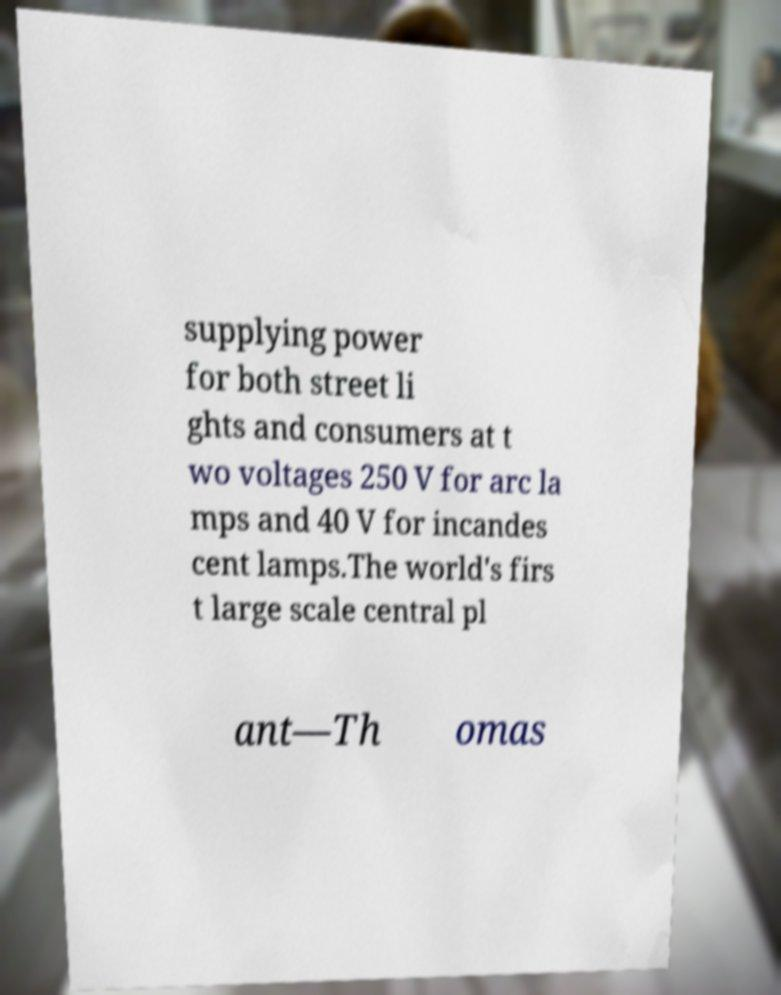Can you accurately transcribe the text from the provided image for me? supplying power for both street li ghts and consumers at t wo voltages 250 V for arc la mps and 40 V for incandes cent lamps.The world's firs t large scale central pl ant—Th omas 